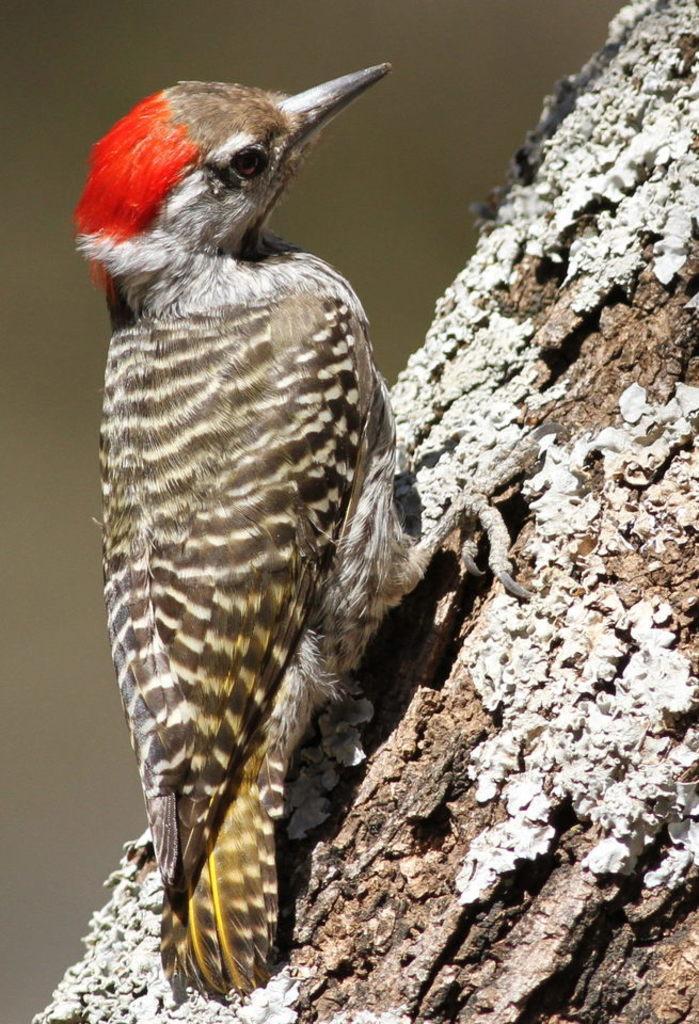In one or two sentences, can you explain what this image depicts? In this picture there is a bird standing on a tree trunk. 